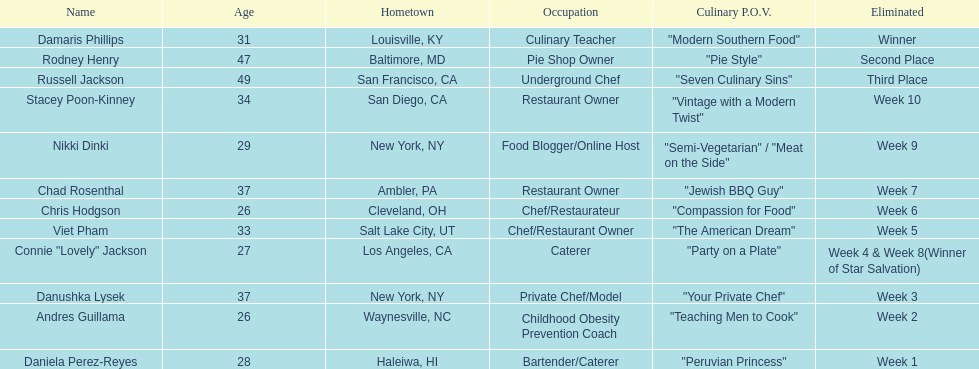In the case of nikki dinki and viet pham, which one was eliminated first? Viet Pham. 